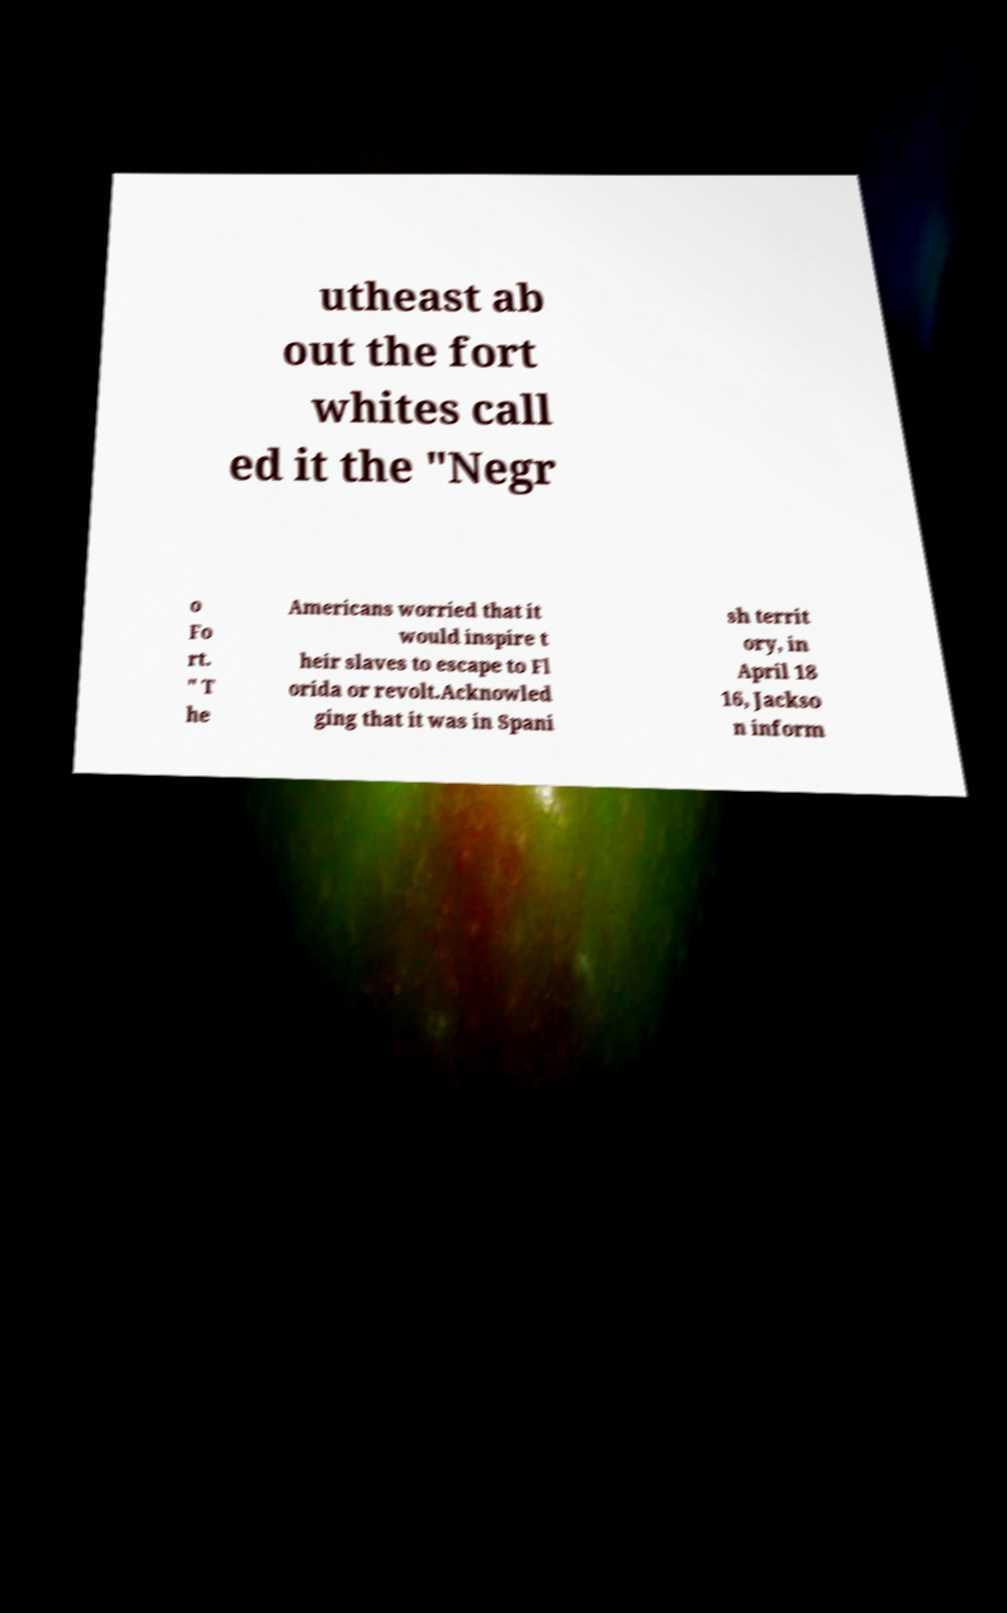What messages or text are displayed in this image? I need them in a readable, typed format. utheast ab out the fort whites call ed it the "Negr o Fo rt. " T he Americans worried that it would inspire t heir slaves to escape to Fl orida or revolt.Acknowled ging that it was in Spani sh territ ory, in April 18 16, Jackso n inform 